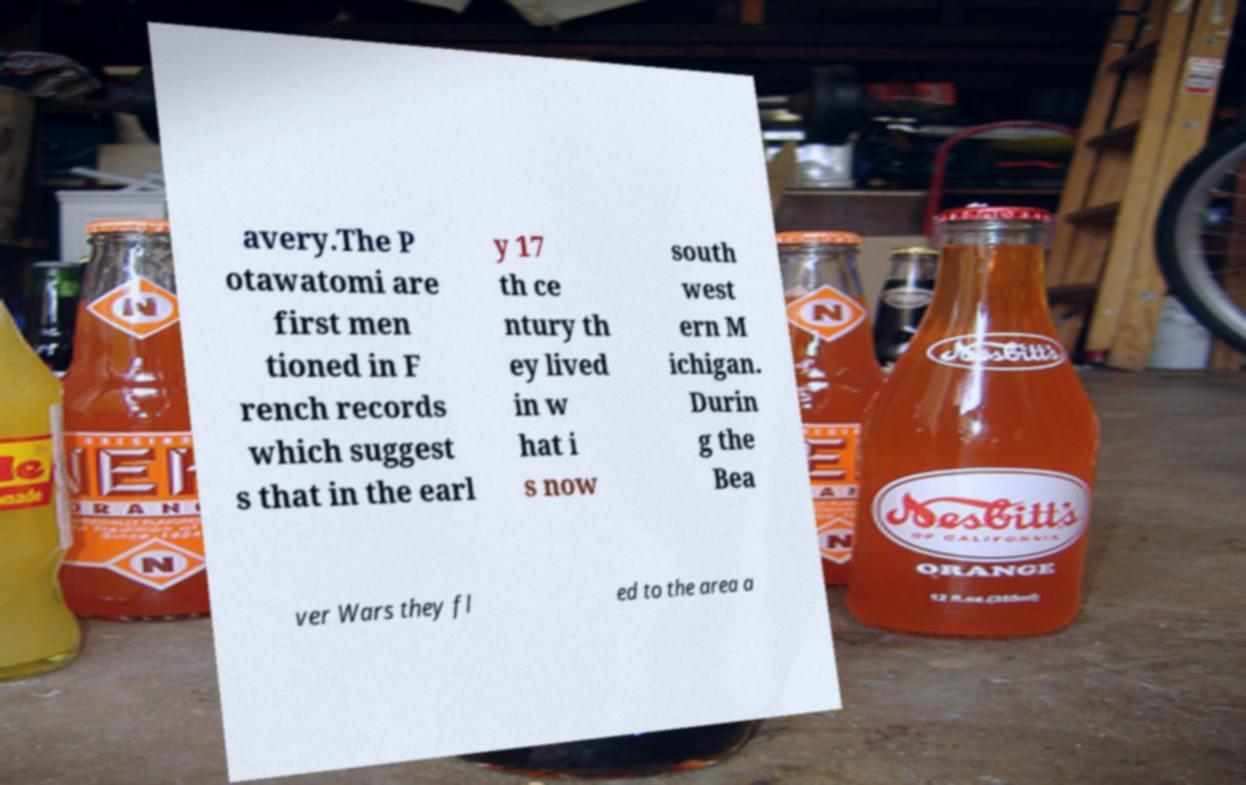Please read and relay the text visible in this image. What does it say? avery.The P otawatomi are first men tioned in F rench records which suggest s that in the earl y 17 th ce ntury th ey lived in w hat i s now south west ern M ichigan. Durin g the Bea ver Wars they fl ed to the area a 